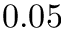<formula> <loc_0><loc_0><loc_500><loc_500>0 . 0 5</formula> 